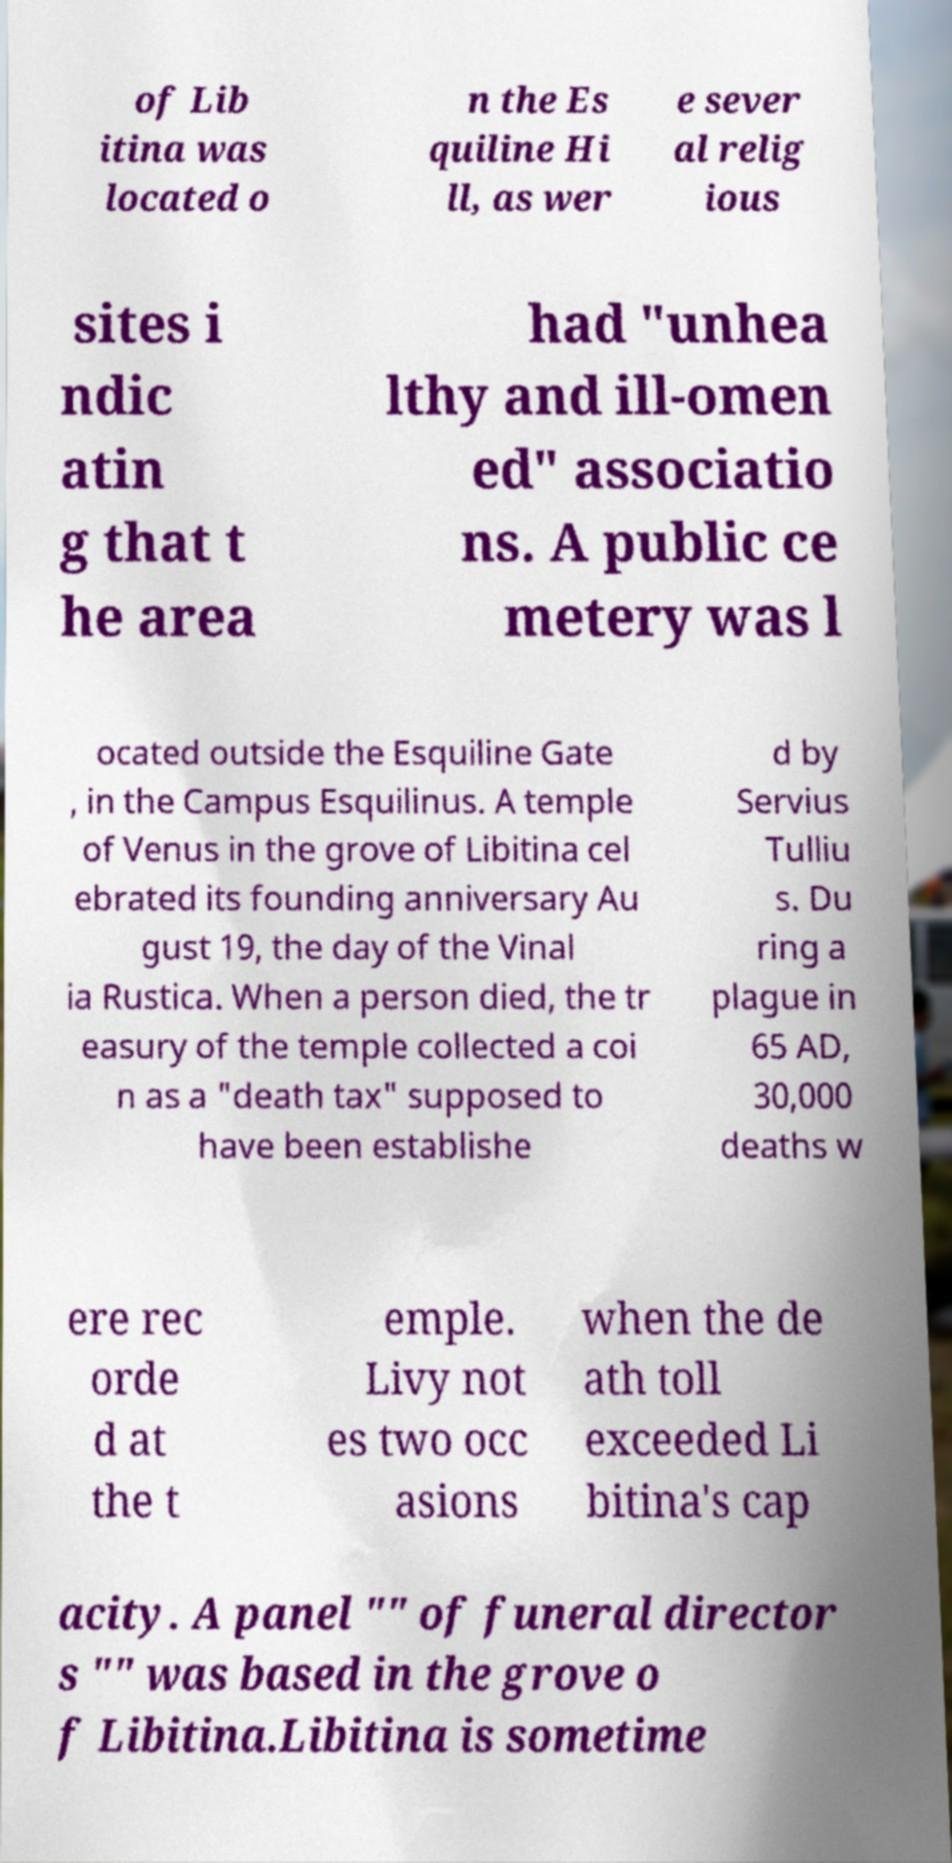What messages or text are displayed in this image? I need them in a readable, typed format. of Lib itina was located o n the Es quiline Hi ll, as wer e sever al relig ious sites i ndic atin g that t he area had "unhea lthy and ill-omen ed" associatio ns. A public ce metery was l ocated outside the Esquiline Gate , in the Campus Esquilinus. A temple of Venus in the grove of Libitina cel ebrated its founding anniversary Au gust 19, the day of the Vinal ia Rustica. When a person died, the tr easury of the temple collected a coi n as a "death tax" supposed to have been establishe d by Servius Tulliu s. Du ring a plague in 65 AD, 30,000 deaths w ere rec orde d at the t emple. Livy not es two occ asions when the de ath toll exceeded Li bitina's cap acity. A panel "" of funeral director s "" was based in the grove o f Libitina.Libitina is sometime 